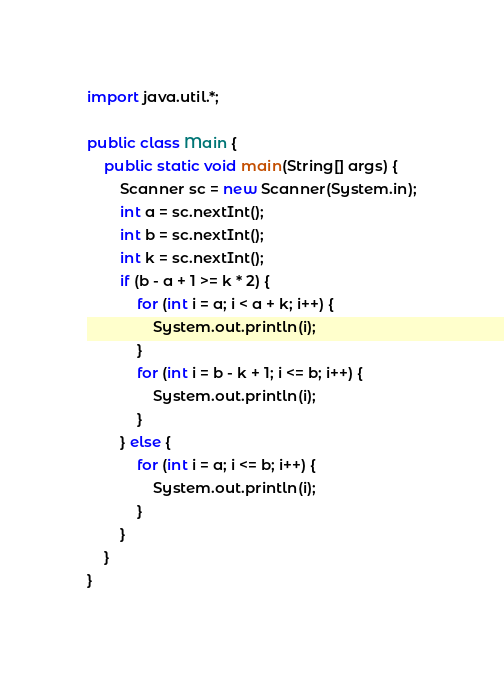<code> <loc_0><loc_0><loc_500><loc_500><_Java_>import java.util.*;

public class Main {
    public static void main(String[] args) {
        Scanner sc = new Scanner(System.in);
        int a = sc.nextInt();
        int b = sc.nextInt();
        int k = sc.nextInt();
        if (b - a + 1 >= k * 2) {
            for (int i = a; i < a + k; i++) {
                System.out.println(i);
            }
            for (int i = b - k + 1; i <= b; i++) {
                System.out.println(i);
            }
        } else {
            for (int i = a; i <= b; i++) {
                System.out.println(i);
            }
        }
    }
}</code> 